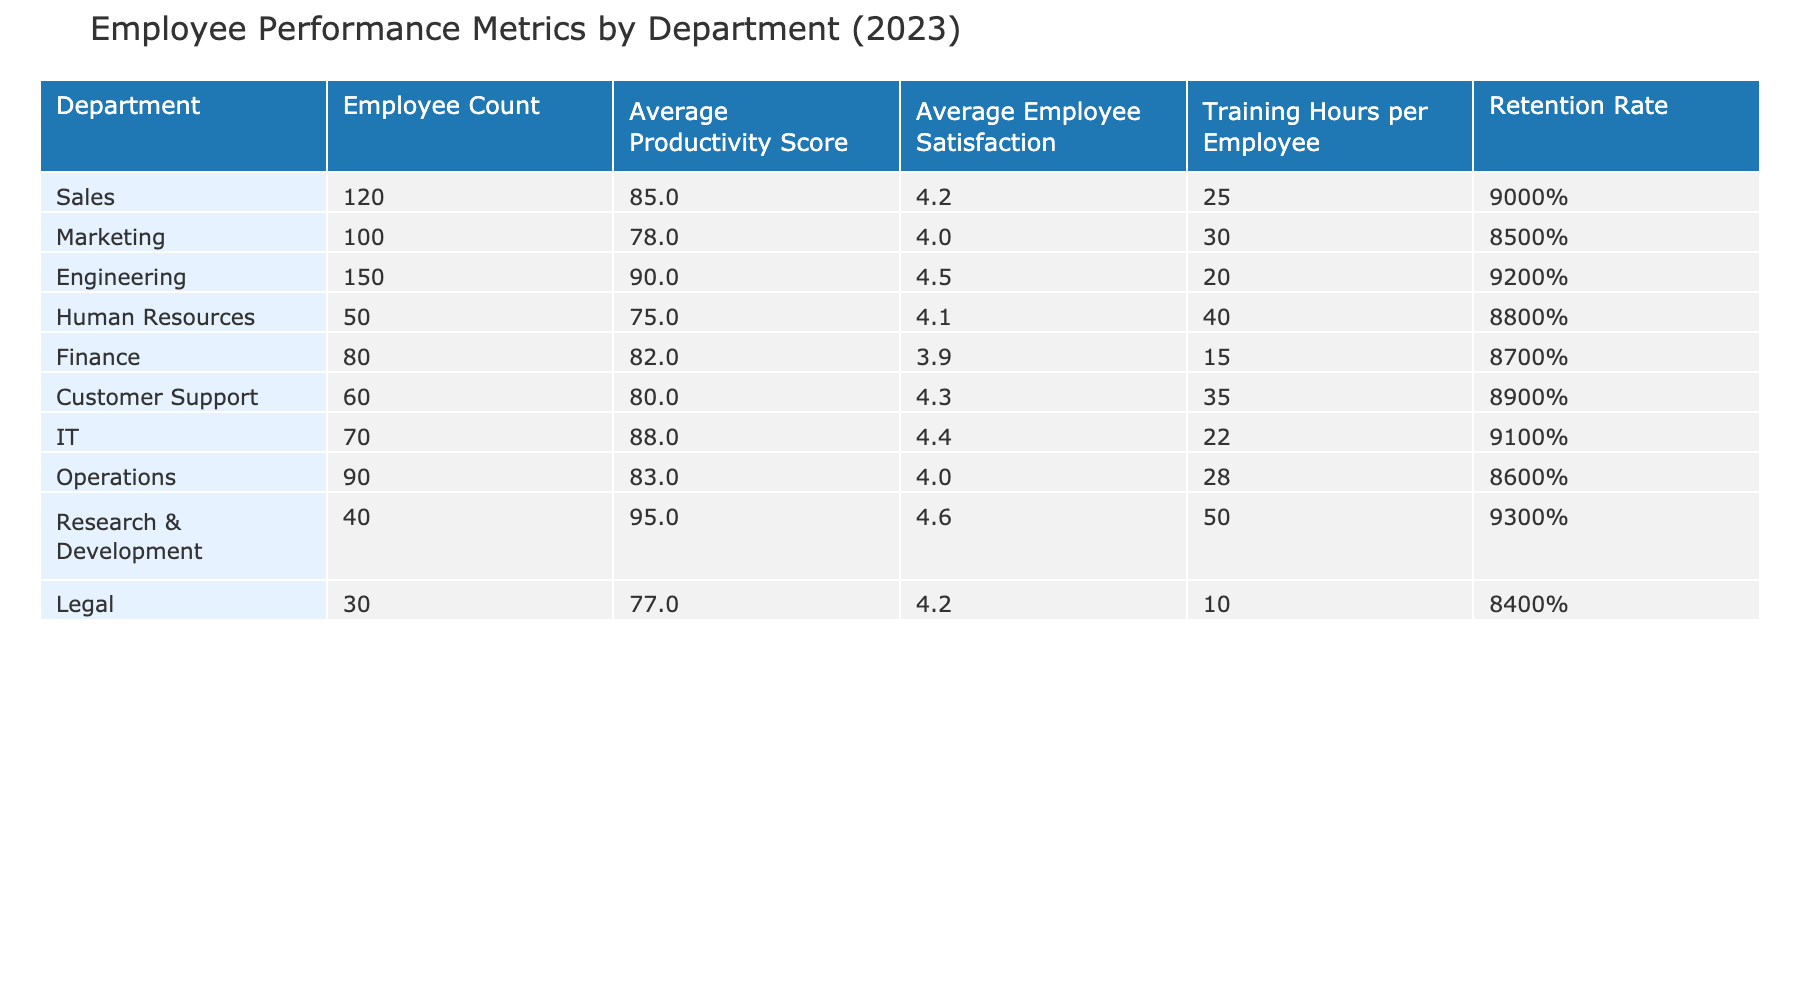What is the average productivity score for the Engineering department? The table shows the average productivity score for the Engineering department directly listed under the respective column, which is 90.
Answer: 90 Which department has the highest retention rate? By comparing the retention rates of all departments in the table, Engineering has the highest retention rate at 92%.
Answer: Engineering Is the average employee satisfaction in the Marketing department greater than 4.0? The table lists the average employee satisfaction for Marketing as 4.0, therefore it is not greater than 4.0.
Answer: No What is the difference in average productivity score between Research & Development and Human Resources? The average productivity score for Research & Development is 95 and for Human Resources, it is 75. The difference is calculated as 95 - 75 = 20.
Answer: 20 Which department has the least number of employees, and what is its retention rate? The table shows that the Legal department has the least number of employees at 30, and its retention rate is listed as 84%.
Answer: Legal, 84% What is the average retention rate for departments with more than 100 employees? The departments with more than 100 employees are Sales (90%), Engineering (92%), and IT (91%). The average is calculated as (90 + 92 + 91) / 3 = 91%.
Answer: 91% Are the average productivity scores for Customer Support and Finance equal? The average productivity score for Customer Support is 80 and for Finance is 82. Since these values are not equal, the answer is no.
Answer: No What is the overall average training hours per employee across all departments? The total training hours are: 25 + 30 + 20 + 40 + 15 + 35 + 22 + 28 + 50 + 10 = 280. There are 10 departments, so the average is 280 / 10 = 28 hours.
Answer: 28 Which department exhibits the highest average employee satisfaction, and what is the score? By reviewing the average employee satisfaction scores, Research & Development scores the highest at 4.6.
Answer: Research & Development, 4.6 